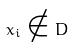Convert formula to latex. <formula><loc_0><loc_0><loc_500><loc_500>x _ { i } \notin D</formula> 